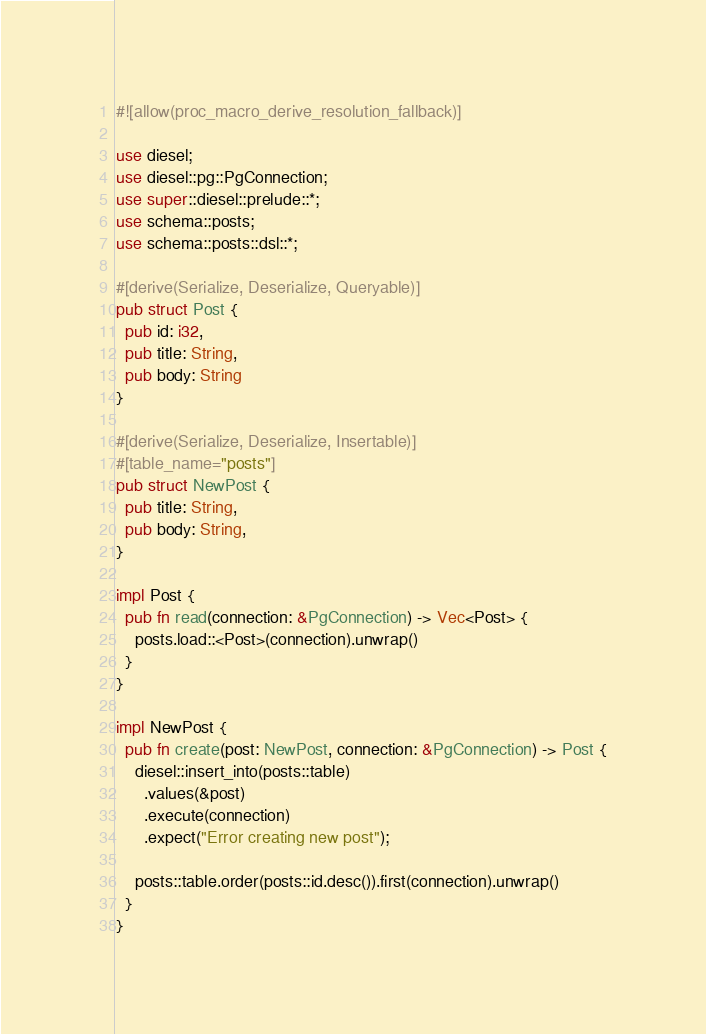Convert code to text. <code><loc_0><loc_0><loc_500><loc_500><_Rust_>#![allow(proc_macro_derive_resolution_fallback)]

use diesel;
use diesel::pg::PgConnection;
use super::diesel::prelude::*;
use schema::posts;
use schema::posts::dsl::*;

#[derive(Serialize, Deserialize, Queryable)]
pub struct Post {
  pub id: i32,
  pub title: String,
  pub body: String
}

#[derive(Serialize, Deserialize, Insertable)]
#[table_name="posts"]
pub struct NewPost {
  pub title: String,
  pub body: String,
}

impl Post {
  pub fn read(connection: &PgConnection) -> Vec<Post> {
    posts.load::<Post>(connection).unwrap()
  }
}

impl NewPost {
  pub fn create(post: NewPost, connection: &PgConnection) -> Post {
    diesel::insert_into(posts::table)
      .values(&post)
      .execute(connection)
      .expect("Error creating new post");

    posts::table.order(posts::id.desc()).first(connection).unwrap()
  }
}
</code> 